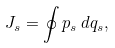Convert formula to latex. <formula><loc_0><loc_0><loc_500><loc_500>J _ { s } = \oint p _ { s } \, d q _ { s } ,</formula> 